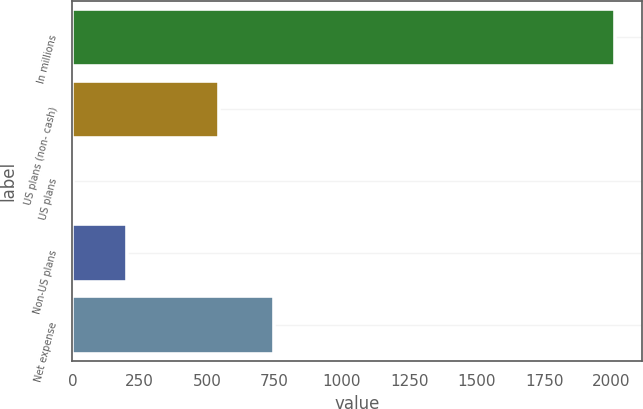<chart> <loc_0><loc_0><loc_500><loc_500><bar_chart><fcel>In millions<fcel>US plans (non- cash)<fcel>US plans<fcel>Non-US plans<fcel>Net expense<nl><fcel>2013<fcel>545<fcel>1<fcel>202.2<fcel>746.2<nl></chart> 